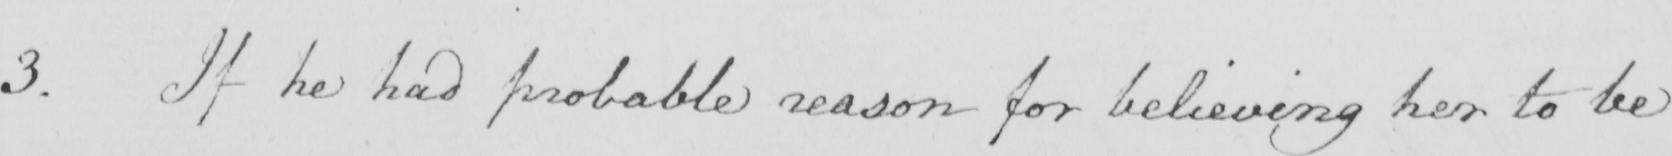Can you tell me what this handwritten text says? 3 . If he had probable reason for believing her to be 